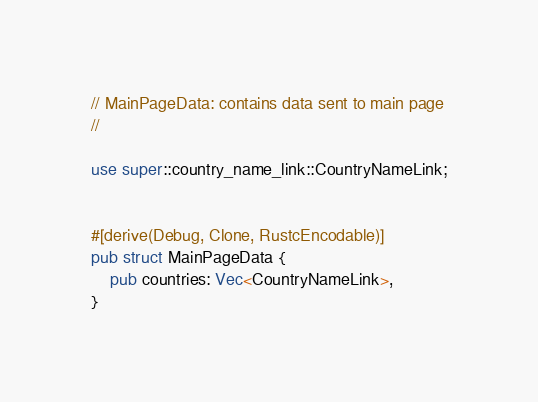<code> <loc_0><loc_0><loc_500><loc_500><_Rust_>// MainPageData: contains data sent to main page
//

use super::country_name_link::CountryNameLink;


#[derive(Debug, Clone, RustcEncodable)]
pub struct MainPageData {
    pub countries: Vec<CountryNameLink>,
}
</code> 